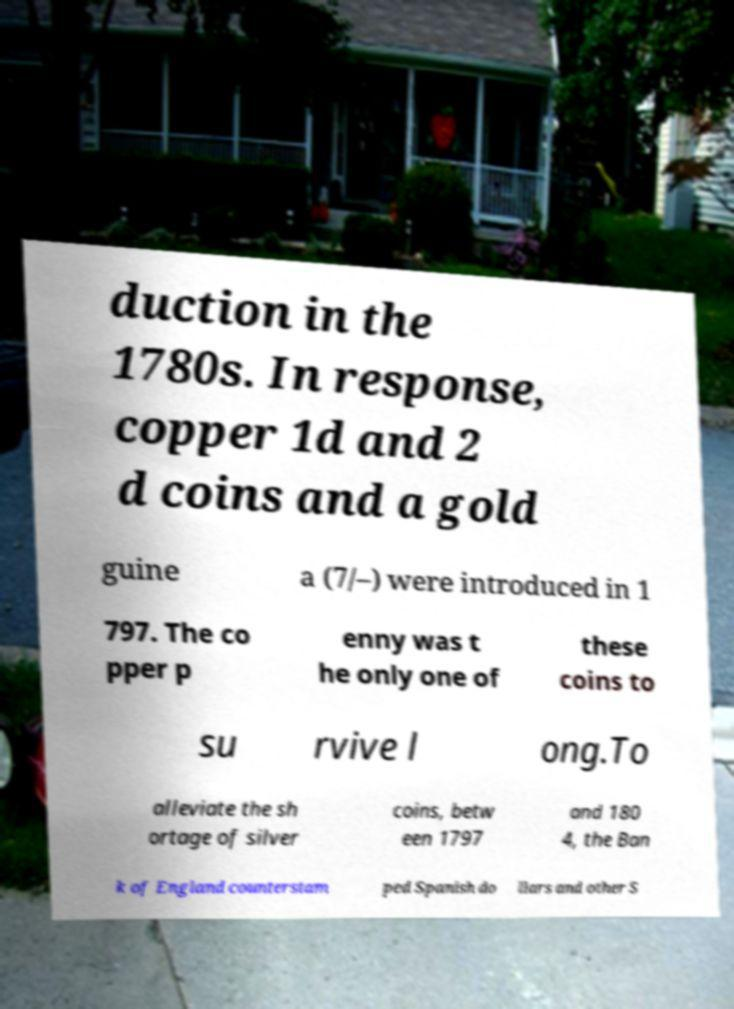Can you read and provide the text displayed in the image?This photo seems to have some interesting text. Can you extract and type it out for me? duction in the 1780s. In response, copper 1d and 2 d coins and a gold guine a (7/–) were introduced in 1 797. The co pper p enny was t he only one of these coins to su rvive l ong.To alleviate the sh ortage of silver coins, betw een 1797 and 180 4, the Ban k of England counterstam ped Spanish do llars and other S 